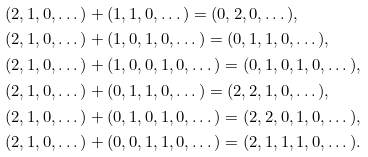<formula> <loc_0><loc_0><loc_500><loc_500>& ( 2 , 1 , 0 , \dots ) + ( 1 , 1 , 0 , \dots ) = ( 0 , 2 , 0 , \dots ) , \\ & ( 2 , 1 , 0 , \dots ) + ( 1 , 0 , 1 , 0 , \dots ) = ( 0 , 1 , 1 , 0 , \dots ) , \\ & ( 2 , 1 , 0 , \dots ) + ( 1 , 0 , 0 , 1 , 0 , \dots ) = ( 0 , 1 , 0 , 1 , 0 , \dots ) , \\ & ( 2 , 1 , 0 , \dots ) + ( 0 , 1 , 1 , 0 , \dots ) = ( 2 , 2 , 1 , 0 , \dots ) , \\ & ( 2 , 1 , 0 , \dots ) + ( 0 , 1 , 0 , 1 , 0 , \dots ) = ( 2 , 2 , 0 , 1 , 0 , \dots ) , \\ & ( 2 , 1 , 0 , \dots ) + ( 0 , 0 , 1 , 1 , 0 , \dots ) = ( 2 , 1 , 1 , 1 , 0 , \dots ) .</formula> 